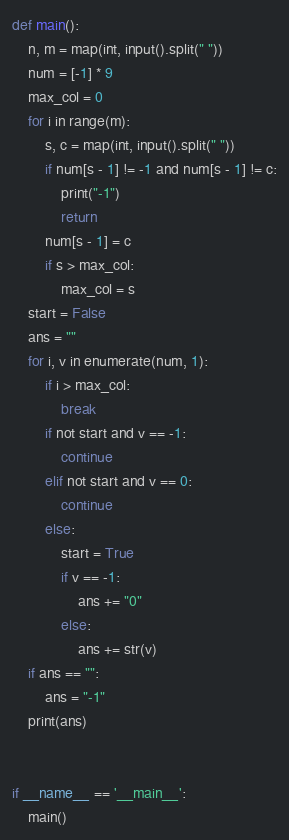Convert code to text. <code><loc_0><loc_0><loc_500><loc_500><_Python_>def main():
    n, m = map(int, input().split(" "))
    num = [-1] * 9
    max_col = 0
    for i in range(m):
        s, c = map(int, input().split(" "))
        if num[s - 1] != -1 and num[s - 1] != c:
            print("-1")
            return
        num[s - 1] = c
        if s > max_col:
            max_col = s
    start = False
    ans = ""
    for i, v in enumerate(num, 1):
        if i > max_col:
            break
        if not start and v == -1:
            continue
        elif not start and v == 0:
            continue
        else:
            start = True
            if v == -1:
                ans += "0"
            else:
                ans += str(v)
    if ans == "":
        ans = "-1"
    print(ans)


if __name__ == '__main__':
    main()
</code> 